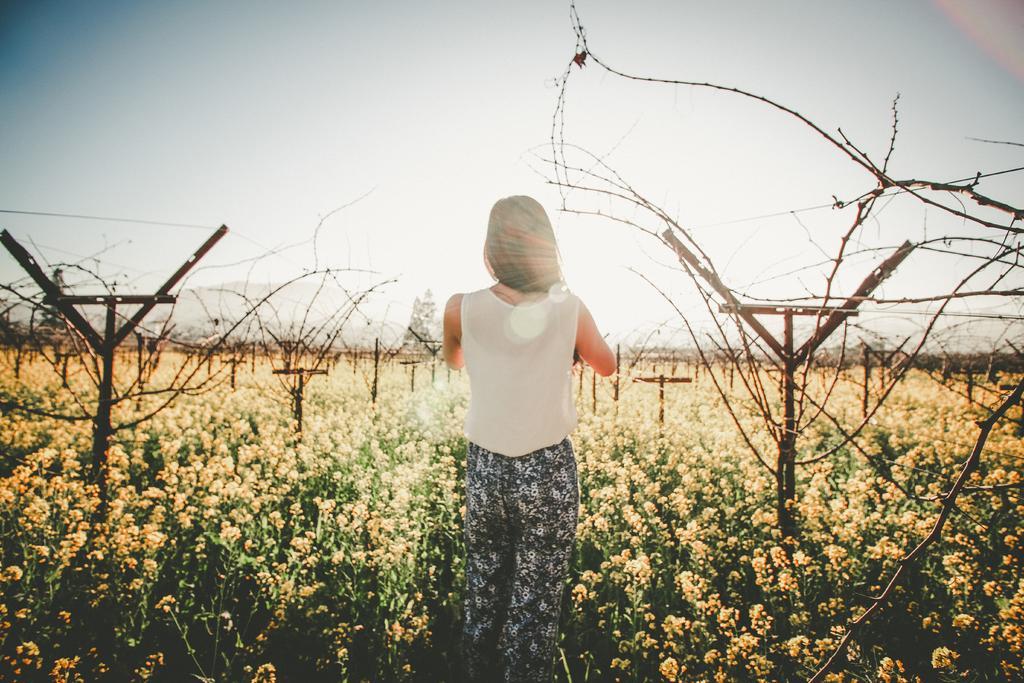Please provide a concise description of this image. In this image in the center there is one woman who is standing, and also there are some trees. At the bottom there are some plants and flowers and also we could see some poles, and at the top of the image there is sky. 